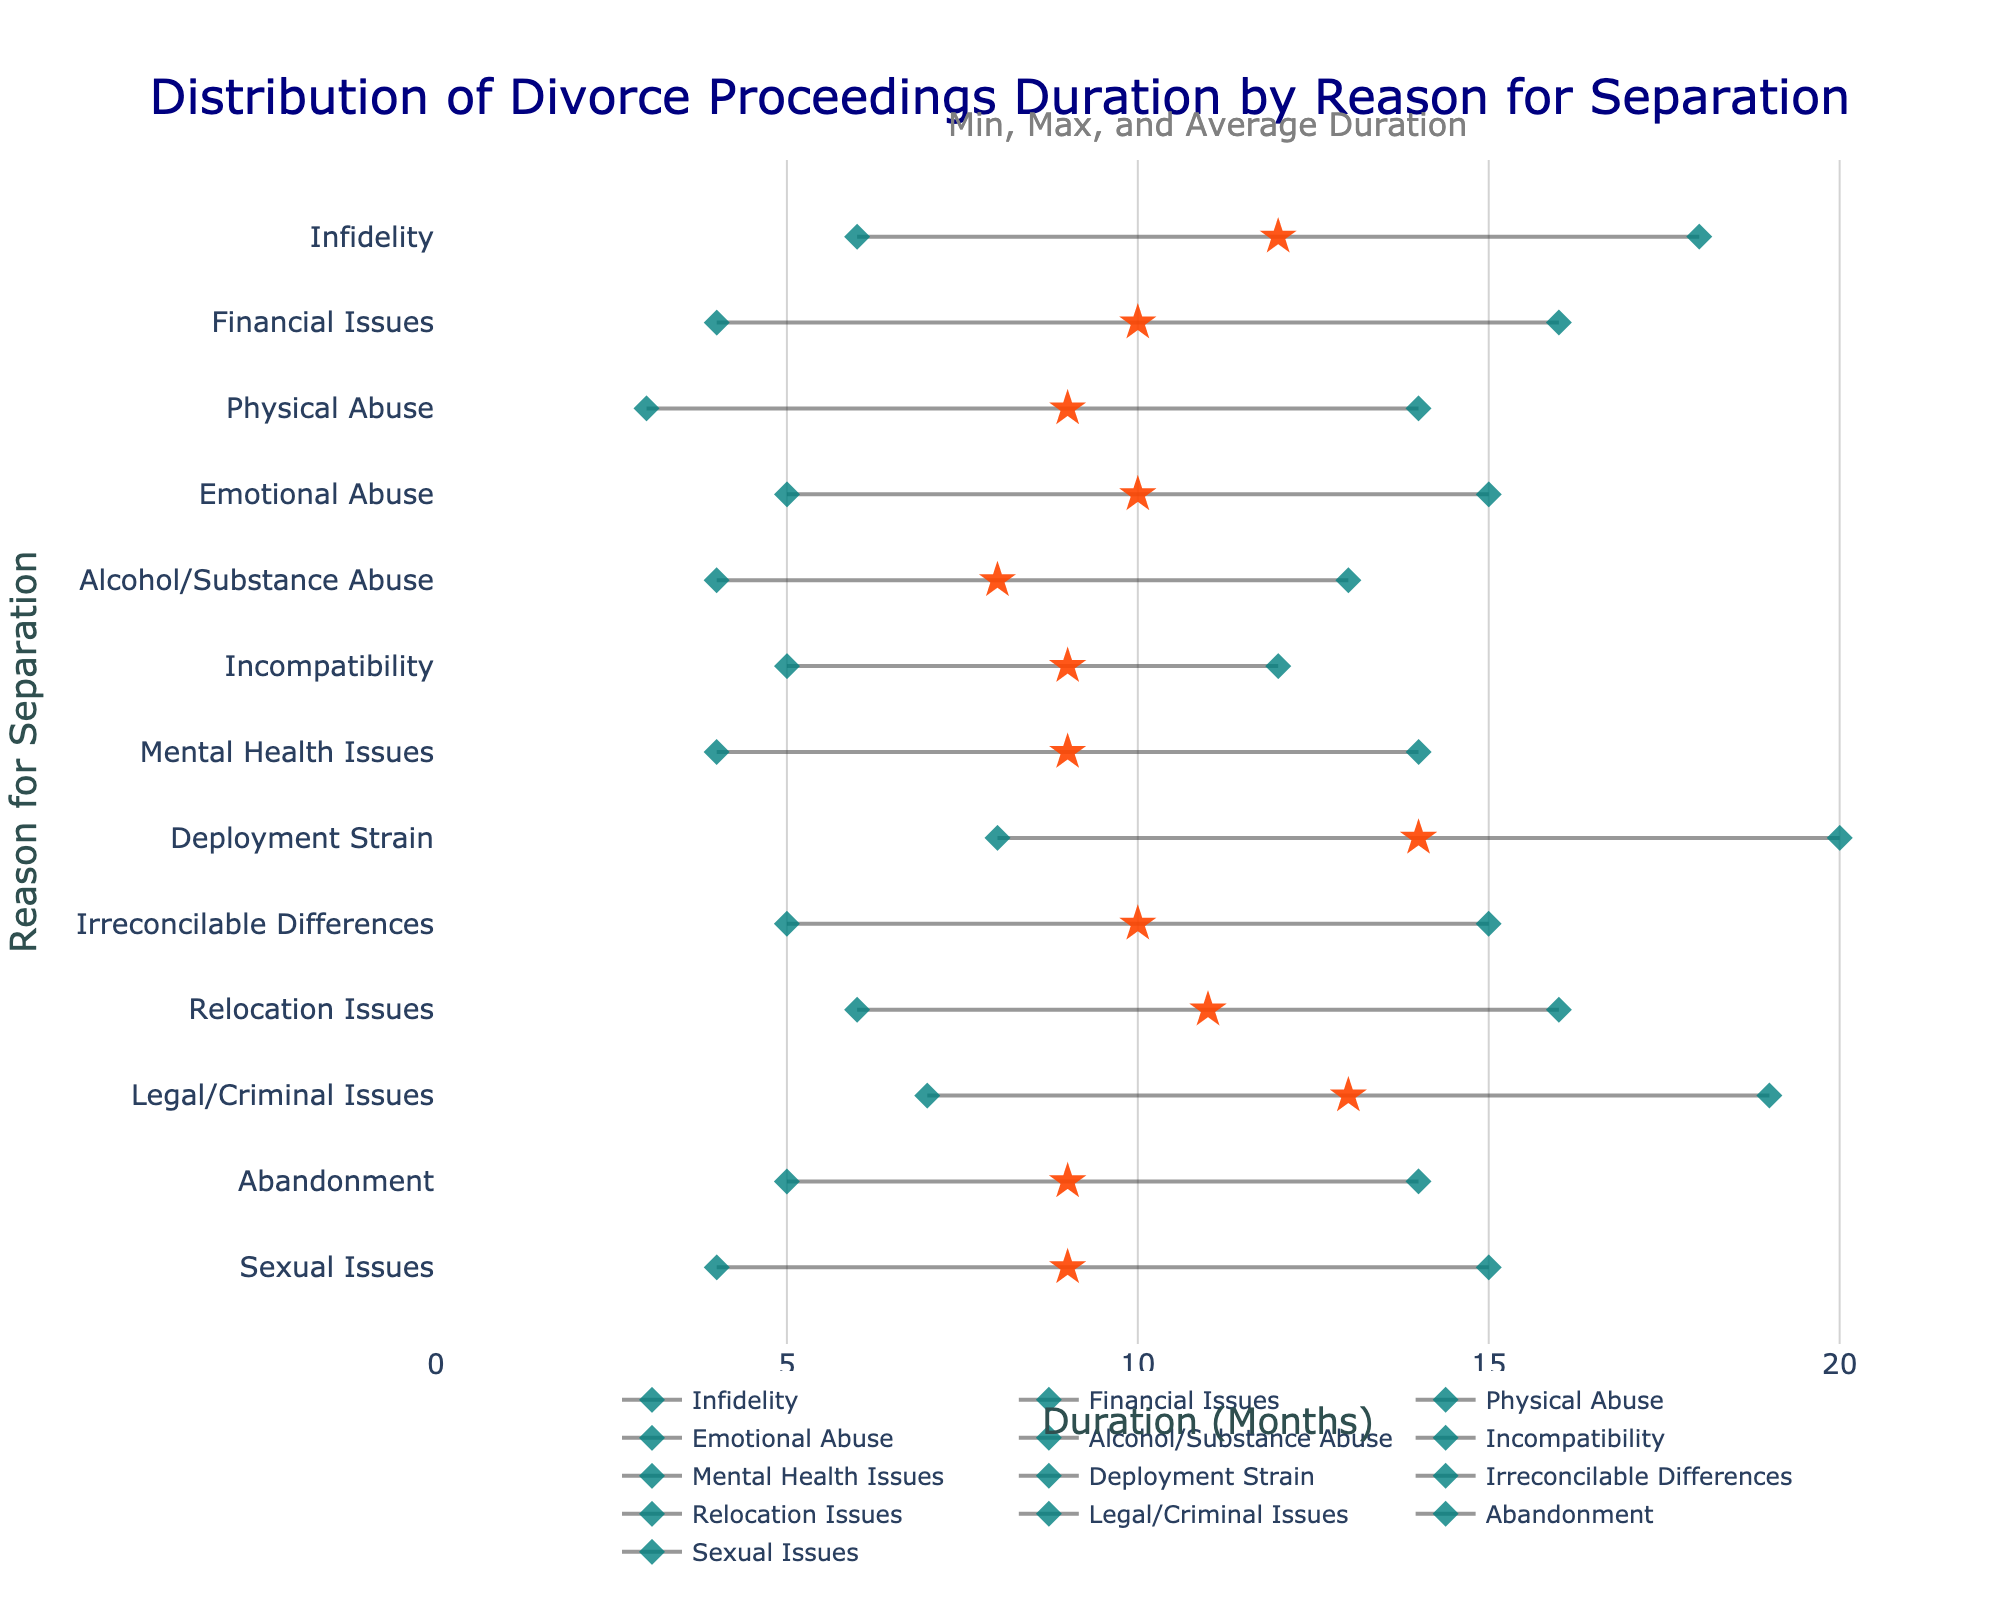What's the title of the chart? The title of the chart is displayed at the top and usually includes the main subject of the data. In this case, the title is "Distribution of Divorce Proceedings Duration by Reason for Separation."
Answer: Distribution of Divorce Proceedings Duration by Reason for Separation What is the average duration of divorce proceedings for Infidelity? Locate the reason "Infidelity" on the y-axis and check the symbol that represents the average duration, which is a star. The x-axis position of this symbol shows the average duration.
Answer: 12 months Which reason for separation has the shortest minimum duration? Look along the entire x-axis for the starting point of each line, representing the minimum duration. Compare the positions to find the smallest value.
Answer: Physical Abuse What's the range of the average durations across all reasons for separation? Identify the average (star symbols) for all reasons and find the minimum and maximum values. Calculate the range by subtracting the smallest average from the largest average. The minimum average is 8 (Alcohol/Substance Abuse), and the maximum average is 14 (Deployment Strain). The range is 14 - 8.
Answer: 6 months Compare the maximum durations for Abandonment and Alcohol/Substance Abuse. Which is longer? Locate the lines corresponding to "Abandonment" and "Alcohol/Substance Abuse" and check the end points that represent the maximum duration on the x-axis. Compare these positions.
Answer: Abandonment Which reason for separation has the highest average duration? Locate the star symbols on the plot and find the one farthest to the right on the x-axis.
Answer: Deployment Strain What is the duration range for Financial Issues? For "Financial Issues," identify the minimum and maximum points on the line. Subtract the minimum duration from the maximum duration found on the x-axis. In this case, the minimum is 4 months and the maximum is 16 months.
Answer: 12 months How does Deployment Strain compare to Infidelity in terms of maximum duration? Find the end points of the lines for both "Deployment Strain" and "Infidelity." Compare the x-axis positions of these end points to see which is higher. Deployment Strain has a maximum duration of 20 months, while Infidelity has a maximum duration of 18 months.
Answer: Deployment Strain is longer What's the total duration range covered by all reasons for separation? Find the smallest minimum value and the largest maximum value across all reasons. Subtract the smallest value (3 months for Physical Abuse) from the largest value (20 months for Deployment Strain).
Answer: 17 months Between Emotional Abuse and Sexual Issues, which has a higher average duration? Locate the star symbols for both "Emotional Abuse" and "Sexual Issues" and compare their positions along the x-axis.
Answer: Emotional Abuse 